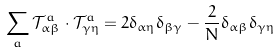Convert formula to latex. <formula><loc_0><loc_0><loc_500><loc_500>\sum _ { a } \mathcal { T } ^ { a } _ { \alpha \beta } \cdot \mathcal { T } ^ { a } _ { \gamma \eta } = 2 \delta _ { \alpha \eta } \delta _ { \beta \gamma } - \frac { 2 } { N } \delta _ { \alpha \beta } \delta _ { \gamma \eta }</formula> 